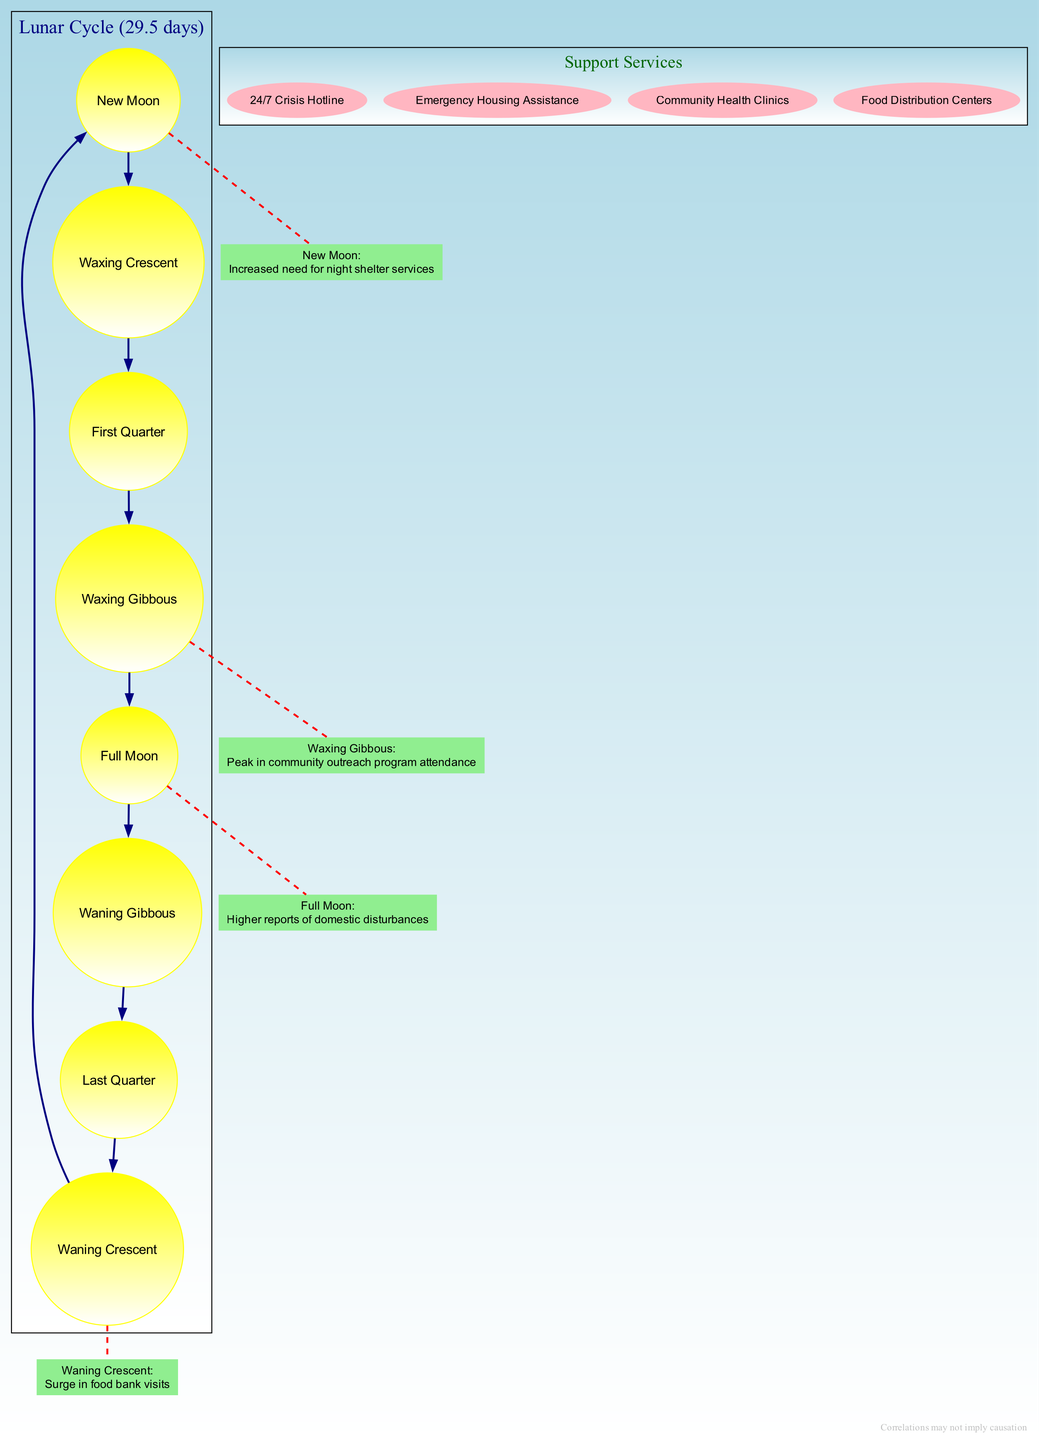What is the first phase of the moon shown in the diagram? The diagram lists the phases of the moon in order, starting from "New Moon." Therefore, the first phase is "New Moon."
Answer: New Moon How many community impacts are listed in the diagram? There are four impacts detailed under community impacts within the diagram, which correspond to specific moon phases.
Answer: Four What behavior is associated with the Full Moon phase? The information indicates that the Full Moon phase is associated with "Higher reports of domestic disturbances."
Answer: Higher reports of domestic disturbances Which moon phase corresponds to a surge in food bank visits? The "Waning Crescent" phase is linked with the surge in food bank visits as stated in the impacts section.
Answer: Waning Crescent What type of node represents the support services in the diagram? The support services are represented by nodes shaped as ellipses, as specified in the subgraph attributes for support services.
Answer: Ellipse Which phase has the highest involvement in community outreach programs? The "Waxing Gibbous" phase is noted for a peak in community outreach program attendance, indicating this phase has the highest involvement.
Answer: Waxing Gibbous How many edges connect the moon phases in the diagram? Each phase connects to its adjacent phase and forms a loop, resulting in a total of eight edges, as there are eight phases.
Answer: Eight What services are mentioned to be available for crisis intervention? The diagram lists "24/7 Crisis Hotline," "Emergency Housing Assistance," "Community Health Clinics," and "Food Distribution Centers" as support services.
Answer: 24/7 Crisis Hotline, Emergency Housing Assistance, Community Health Clinics, Food Distribution Centers What is the lunar cycle duration mentioned in the diagram? The duration of the lunar cycle provided in the diagram is noted to be 29.5 days.
Answer: 29.5 days 